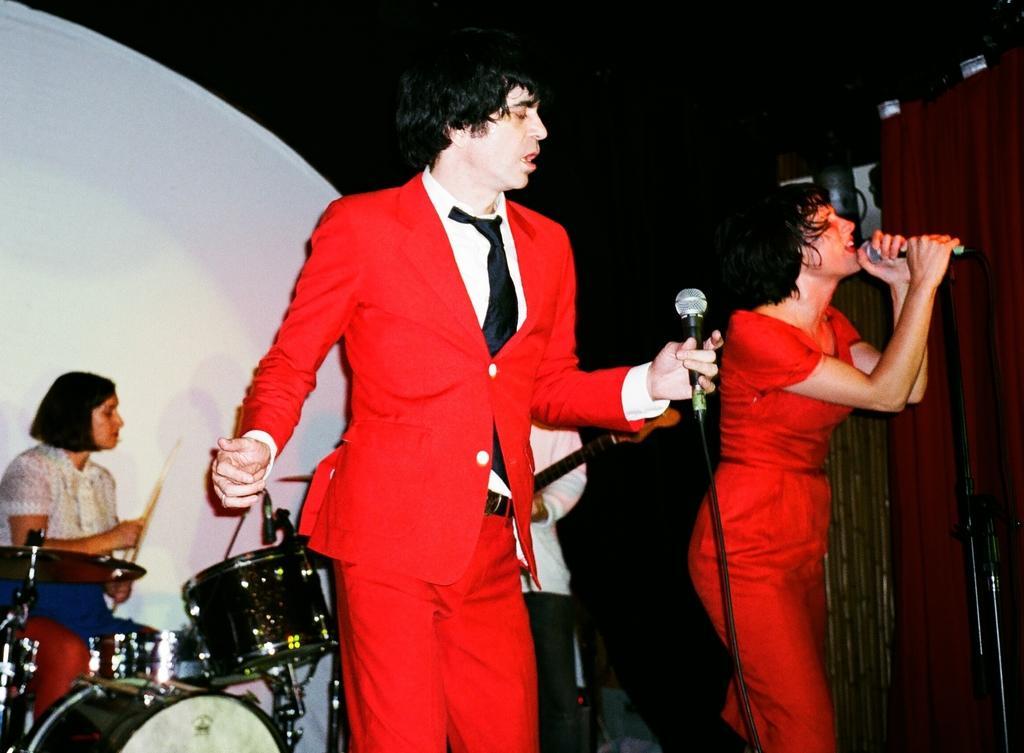How would you summarize this image in a sentence or two? In the middle of the image two persons are standing and holding microphones. Behind them two persons are playing some musical instruments. 